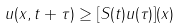<formula> <loc_0><loc_0><loc_500><loc_500>u ( x , t + \tau ) \geq [ S ( t ) u ( \tau ) ] ( x )</formula> 